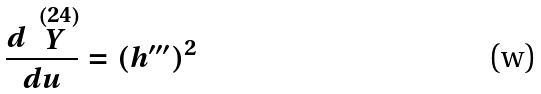<formula> <loc_0><loc_0><loc_500><loc_500>\frac { d \stackrel { ( 2 4 ) } { Y } } { d u } = ( h ^ { \prime \prime \prime } ) ^ { 2 }</formula> 